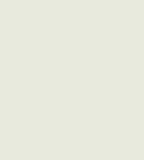<code> <loc_0><loc_0><loc_500><loc_500><_Julia_>
</code> 